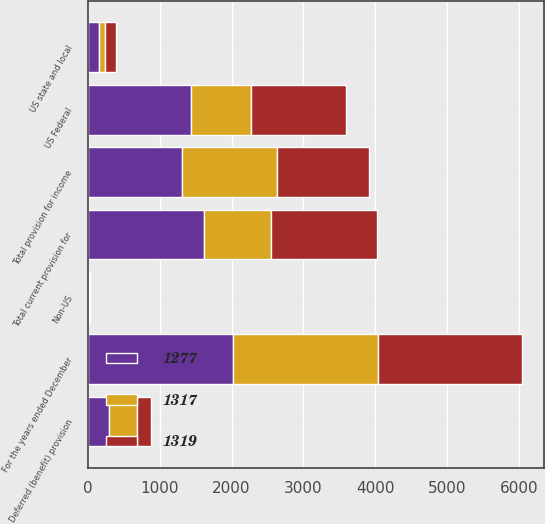Convert chart to OTSL. <chart><loc_0><loc_0><loc_500><loc_500><stacked_bar_chart><ecel><fcel>For the years ended December<fcel>US Federal<fcel>US state and local<fcel>Non-US<fcel>Total current provision for<fcel>Deferred (benefit) provision<fcel>Total provision for income<nl><fcel>1317<fcel>2016<fcel>829<fcel>86<fcel>15<fcel>930<fcel>389<fcel>1319<nl><fcel>1277<fcel>2015<fcel>1443<fcel>158<fcel>11<fcel>1612<fcel>295<fcel>1317<nl><fcel>1319<fcel>2014<fcel>1320<fcel>153<fcel>7<fcel>1480<fcel>203<fcel>1277<nl></chart> 